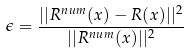<formula> <loc_0><loc_0><loc_500><loc_500>\epsilon = \frac { | | R ^ { n u m } ( x ) - R ( x ) | | ^ { 2 } } { | | R ^ { n u m } ( x ) | | ^ { 2 } }</formula> 